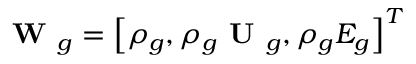Convert formula to latex. <formula><loc_0><loc_0><loc_500><loc_500>W _ { g } = \left [ \rho _ { g } , \rho _ { g } U _ { g } , \rho _ { g } E _ { g } \right ] ^ { T }</formula> 